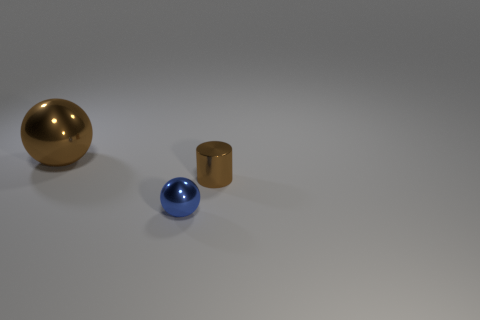Are the objects positioned in any particular pattern? The objects are arranged linearly across the image with even spacing, which creates a sense of balance in the composition. They are placed against a neutral background, which allows each object to stand out. Such an arrangement could be intentional to showcase their individual characteristics or be a simplistic artistic choice. Does the arrangement suggest anything about their relative importance or function? The arrangement does not suggest a specific hierarchy or function. Since the objects differ in color and possibly material, the linear display might be intended to highlight these differences or for a purely aesthetic purpose. The simplicity of the arrangement leaves it open to interpretation and does not inherently imply any relative importance or function between the objects. 